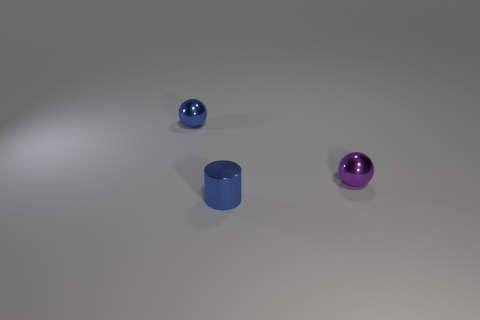Do the blue thing behind the blue metallic cylinder and the sphere to the right of the small cylinder have the same material?
Make the answer very short. Yes. Are there any other things that are the same shape as the small purple metal thing?
Offer a very short reply. Yes. Is the tiny cylinder made of the same material as the small sphere behind the small purple shiny sphere?
Your response must be concise. Yes. What is the color of the small shiny thing that is behind the purple metallic sphere that is on the right side of the sphere to the left of the tiny purple object?
Ensure brevity in your answer.  Blue. There is a blue metallic object that is the same size as the blue metal sphere; what shape is it?
Give a very brief answer. Cylinder. Is there any other thing that has the same size as the purple sphere?
Provide a succinct answer. Yes. Do the blue object that is to the left of the small metallic cylinder and the blue metallic object on the right side of the blue metallic sphere have the same size?
Your response must be concise. Yes. There is a blue metallic object in front of the blue metal sphere; what is its size?
Give a very brief answer. Small. There is a thing that is the same color as the cylinder; what is it made of?
Your answer should be compact. Metal. What color is the other ball that is the same size as the purple shiny ball?
Your answer should be compact. Blue. 